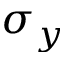Convert formula to latex. <formula><loc_0><loc_0><loc_500><loc_500>\sigma _ { y }</formula> 